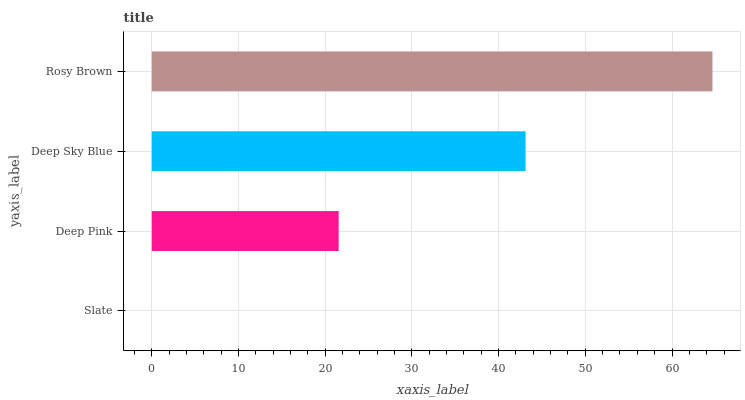Is Slate the minimum?
Answer yes or no. Yes. Is Rosy Brown the maximum?
Answer yes or no. Yes. Is Deep Pink the minimum?
Answer yes or no. No. Is Deep Pink the maximum?
Answer yes or no. No. Is Deep Pink greater than Slate?
Answer yes or no. Yes. Is Slate less than Deep Pink?
Answer yes or no. Yes. Is Slate greater than Deep Pink?
Answer yes or no. No. Is Deep Pink less than Slate?
Answer yes or no. No. Is Deep Sky Blue the high median?
Answer yes or no. Yes. Is Deep Pink the low median?
Answer yes or no. Yes. Is Slate the high median?
Answer yes or no. No. Is Slate the low median?
Answer yes or no. No. 